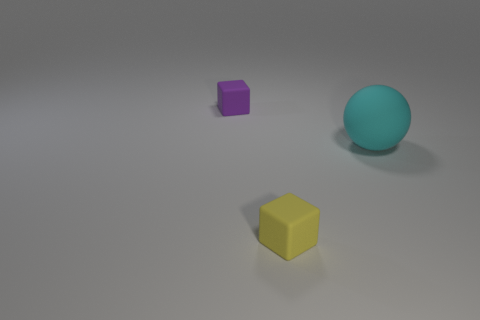How big is the matte block that is in front of the rubber block on the left side of the small yellow rubber block?
Ensure brevity in your answer.  Small. Do the small cube behind the large cyan matte sphere and the small cube in front of the purple rubber object have the same material?
Your response must be concise. Yes. The thing that is both in front of the small purple rubber cube and behind the small yellow matte block is made of what material?
Provide a short and direct response. Rubber. There is a purple matte thing; is it the same shape as the small object that is to the right of the purple matte block?
Offer a very short reply. Yes. How many other objects are the same size as the yellow block?
Your answer should be compact. 1. How many big matte spheres are in front of the cyan object that is in front of the small rubber cube that is behind the matte ball?
Your answer should be very brief. 0. What is the material of the block behind the object in front of the large cyan ball?
Ensure brevity in your answer.  Rubber. Are there any purple objects of the same shape as the yellow thing?
Provide a succinct answer. Yes. The other matte cube that is the same size as the purple matte cube is what color?
Make the answer very short. Yellow. What number of things are either matte things that are on the left side of the big cyan matte object or tiny things behind the tiny yellow matte cube?
Keep it short and to the point. 2. 